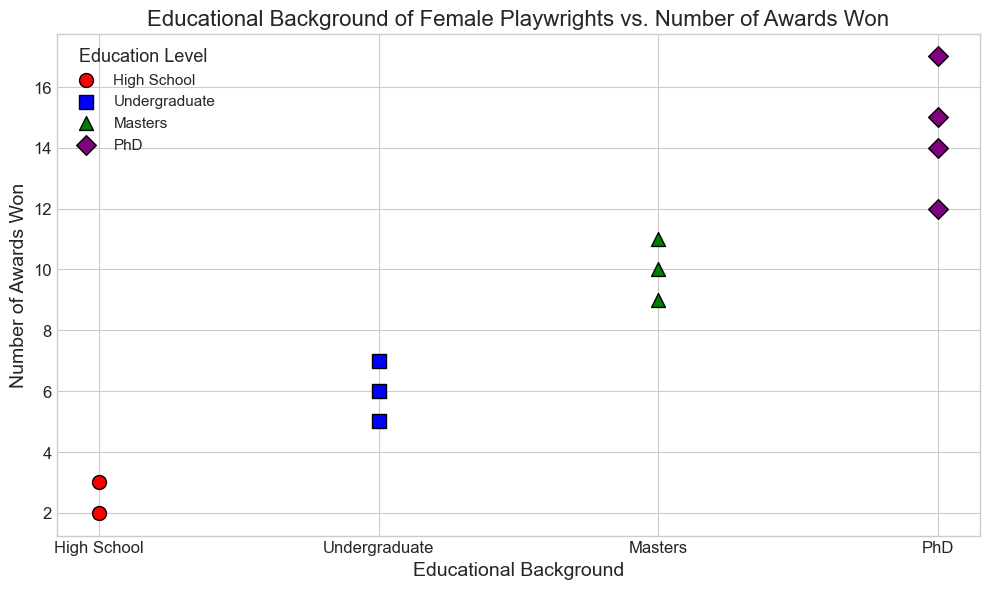Which education level has the highest average number of awards won? To determine this, calculate the average number of awards for each educational level. Sum the number of awards for each level and divide by the count of data points in each level. For High School: (2 + 3) / 2 = 2.5, for Undergraduate: (5 + 7 + 6) / 3 = 6, for Masters: (9 + 10 + 11) / 3 = 10, and for PhD: (12 + 15 + 14 + 17) / 4 = 14.5. Therefore, PhD has the highest average number of awards.
Answer: PhD Which individual has won the most awards? What is their educational background? Look for the highest single award value on the y-axis and identify the corresponding education level. The highest number of awards is 17, which is associated with PhD.
Answer: PhD with 17 awards What is the difference in the average number of awards won between Masters and Undergraduate levels? Calculate the average number of awards for each level and find the difference. For Undergraduate: (5 + 7 + 6) / 3 = 6, and for Masters: (9 + 10 + 11) / 3 = 10. The difference is 10 - 6 = 4.
Answer: 4 Which education level has the most variability in the number of awards won? Variability can be visually estimated by the spread of the points on the y-axis. PhD points show a broader range (spread from 12 to 17) compared to other levels, indicating higher variability.
Answer: PhD Are there any educational levels where the number of awards won is the same across individuals? Check if any educational level has points at the same y-axis value. All levels have variability in the number of awards; none have the same number of awards won across all individuals.
Answer: No What is the median number of awards won by individuals with a PhD? List the number of awards won by individuals with a PhD: [12, 14, 15, 17]. The median for an even number of data points is the average of the middle two numbers: (14 + 15) / 2 = 14.5.
Answer: 14.5 Which educational background has no individuals winning less than 5 awards? Identify the lowest number of awards for each education level. For High School: 2, Undergraduate: 5, Masters: 9, and PhD: 12. Only Masters and PhD have no individuals winning less than 5 awards.
Answer: Masters, PhD 